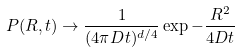<formula> <loc_0><loc_0><loc_500><loc_500>P ( { R } , t ) \rightarrow \frac { 1 } { ( 4 \pi D t ) ^ { d / 4 } } \exp - \frac { R ^ { 2 } } { 4 D t }</formula> 